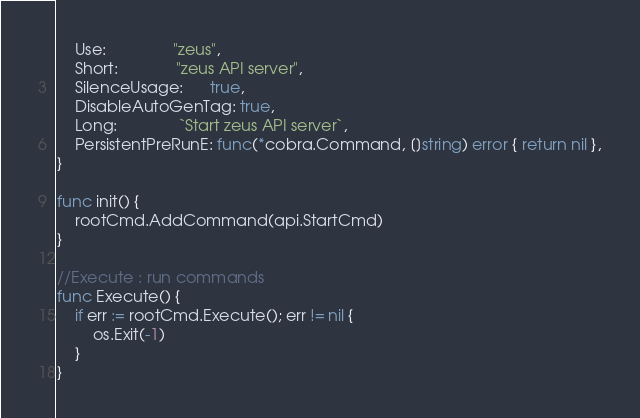Convert code to text. <code><loc_0><loc_0><loc_500><loc_500><_Go_>	Use:               "zeus",
	Short:             "zeus API server",
	SilenceUsage:      true,
	DisableAutoGenTag: true,
	Long:              `Start zeus API server`,
	PersistentPreRunE: func(*cobra.Command, []string) error { return nil },
}

func init() {
	rootCmd.AddCommand(api.StartCmd)
}

//Execute : run commands
func Execute() {
	if err := rootCmd.Execute(); err != nil {
		os.Exit(-1)
	}
}
</code> 